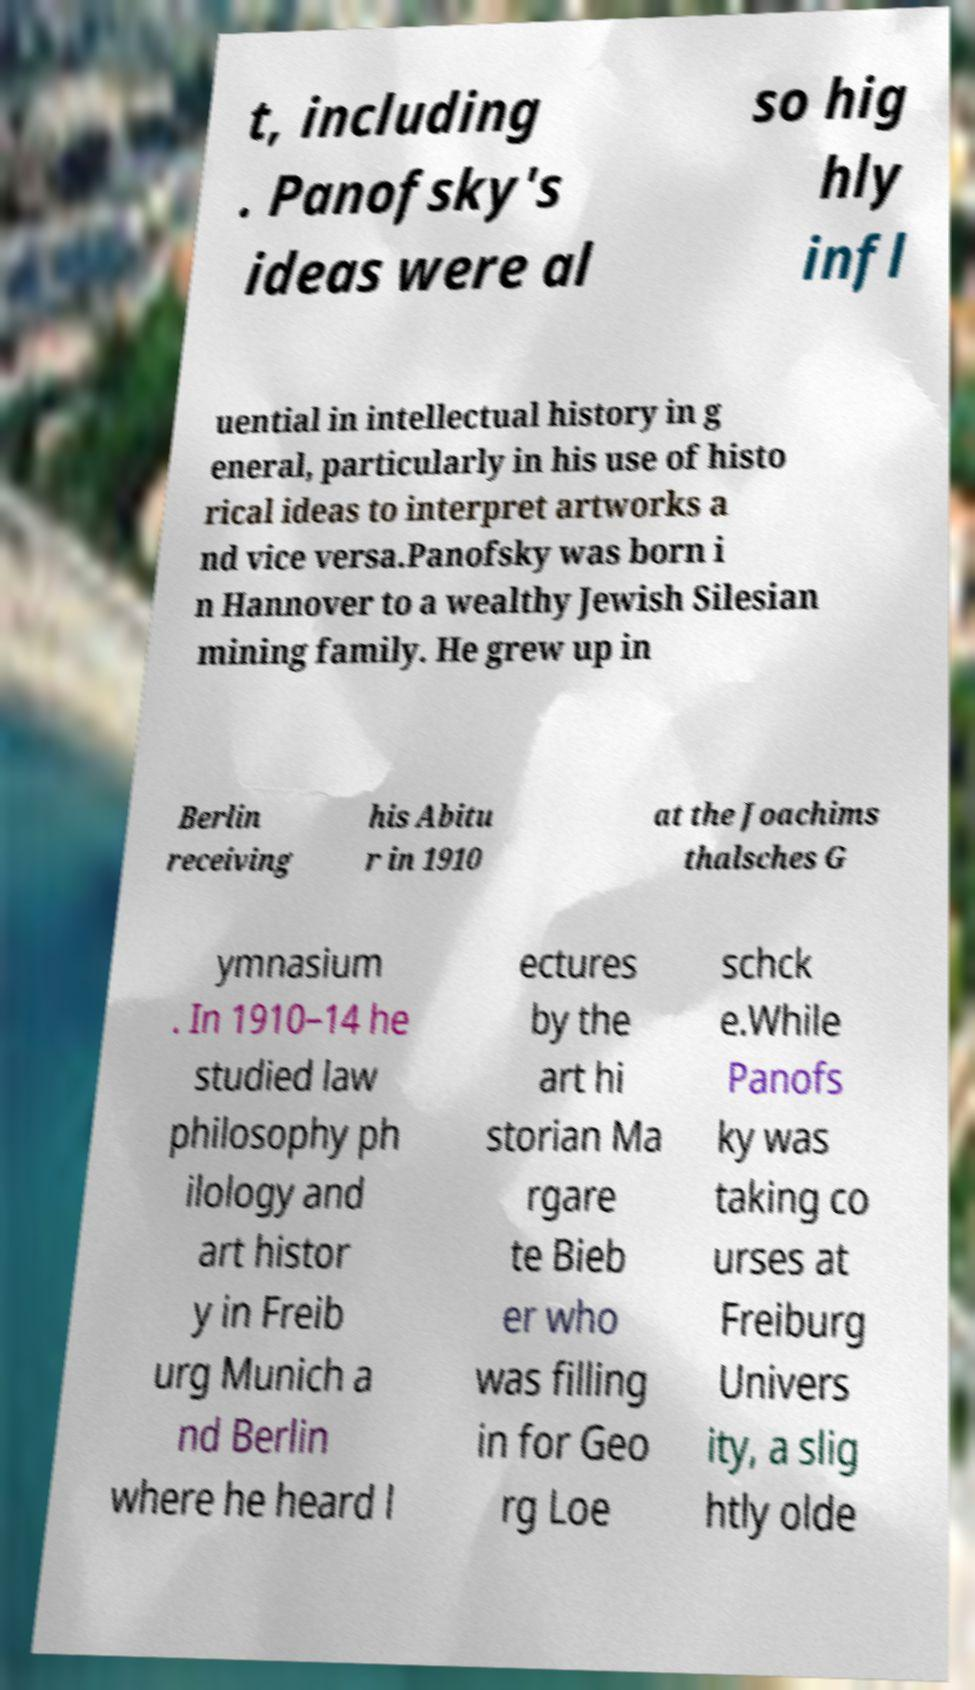There's text embedded in this image that I need extracted. Can you transcribe it verbatim? t, including . Panofsky's ideas were al so hig hly infl uential in intellectual history in g eneral, particularly in his use of histo rical ideas to interpret artworks a nd vice versa.Panofsky was born i n Hannover to a wealthy Jewish Silesian mining family. He grew up in Berlin receiving his Abitu r in 1910 at the Joachims thalsches G ymnasium . In 1910–14 he studied law philosophy ph ilology and art histor y in Freib urg Munich a nd Berlin where he heard l ectures by the art hi storian Ma rgare te Bieb er who was filling in for Geo rg Loe schck e.While Panofs ky was taking co urses at Freiburg Univers ity, a slig htly olde 